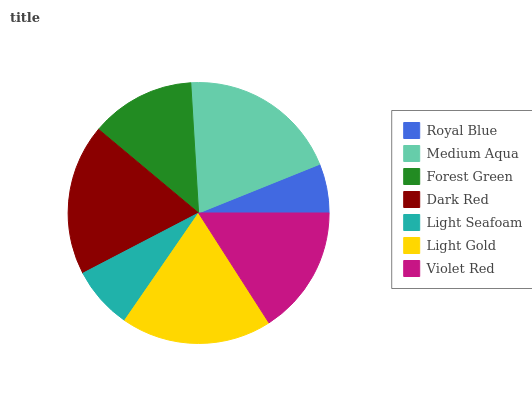Is Royal Blue the minimum?
Answer yes or no. Yes. Is Medium Aqua the maximum?
Answer yes or no. Yes. Is Forest Green the minimum?
Answer yes or no. No. Is Forest Green the maximum?
Answer yes or no. No. Is Medium Aqua greater than Forest Green?
Answer yes or no. Yes. Is Forest Green less than Medium Aqua?
Answer yes or no. Yes. Is Forest Green greater than Medium Aqua?
Answer yes or no. No. Is Medium Aqua less than Forest Green?
Answer yes or no. No. Is Violet Red the high median?
Answer yes or no. Yes. Is Violet Red the low median?
Answer yes or no. Yes. Is Dark Red the high median?
Answer yes or no. No. Is Light Gold the low median?
Answer yes or no. No. 